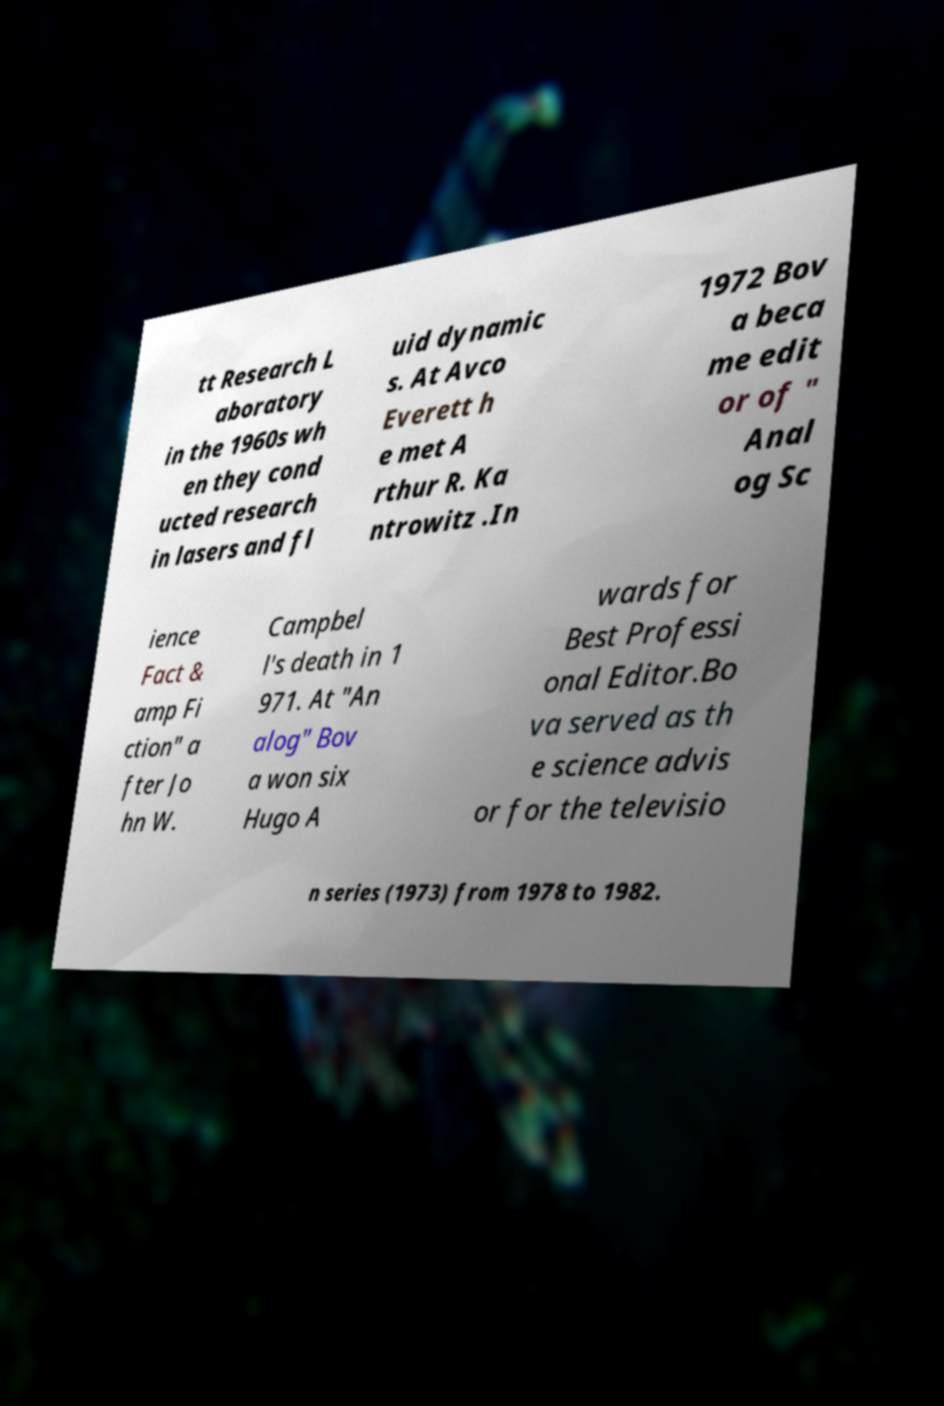Please identify and transcribe the text found in this image. tt Research L aboratory in the 1960s wh en they cond ucted research in lasers and fl uid dynamic s. At Avco Everett h e met A rthur R. Ka ntrowitz .In 1972 Bov a beca me edit or of " Anal og Sc ience Fact & amp Fi ction" a fter Jo hn W. Campbel l's death in 1 971. At "An alog" Bov a won six Hugo A wards for Best Professi onal Editor.Bo va served as th e science advis or for the televisio n series (1973) from 1978 to 1982. 